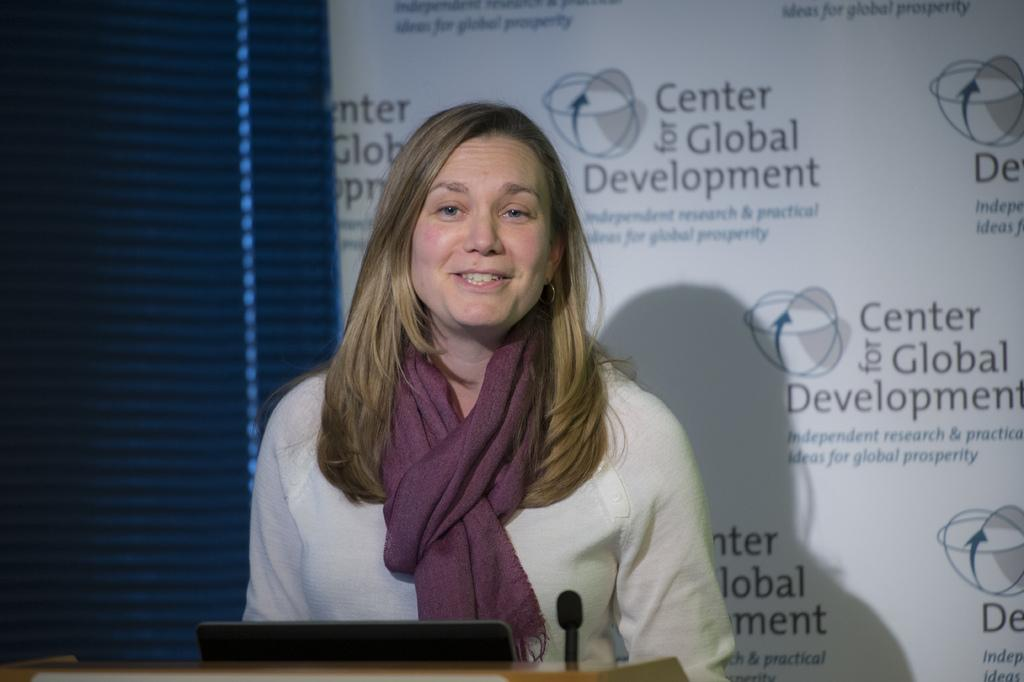Who is present in the image? There is a woman in the image. What is the woman doing in the image? The woman is standing near a microphone. What can be seen in the background of the image? There is a wall in the background of the image. What is written on the wall? There is text written on the wall. What type of eggnog is being served at the slave auction in the image? There is no reference to a slave auction or eggnog in the image; it features a woman standing near a microphone with a wall in the background. 